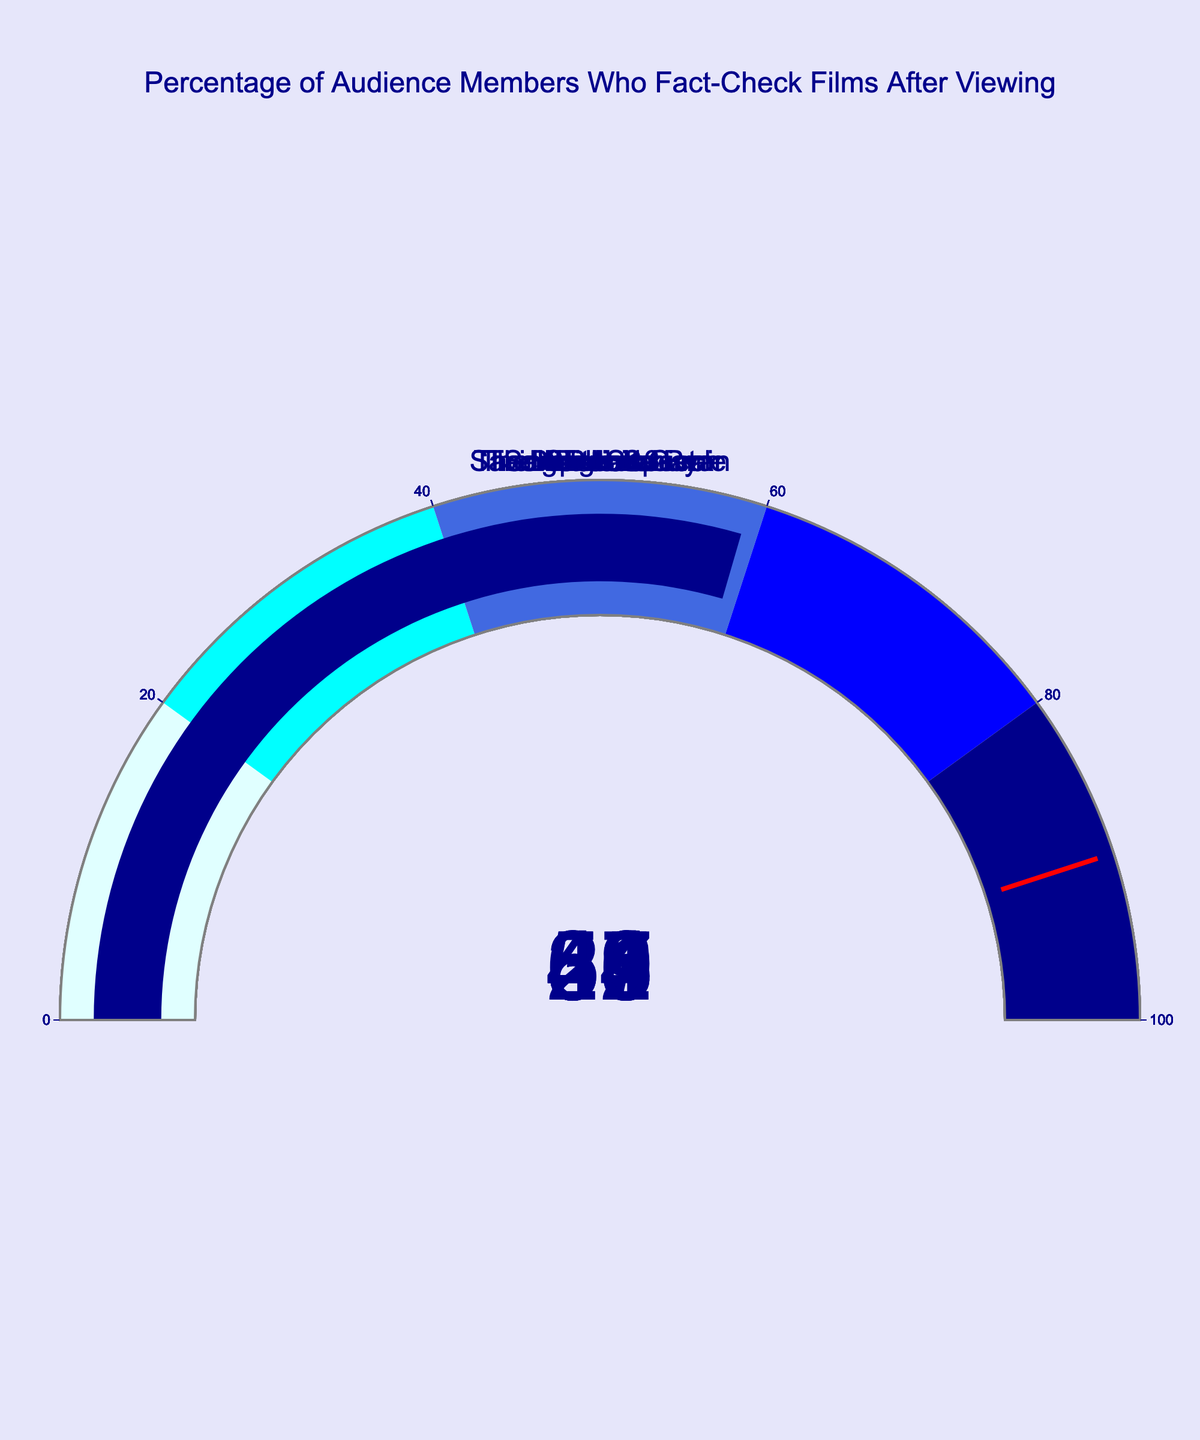what movie has the highest percentage of audience members who fact-check it after viewing? The gauge chart displays different movies with their respective percentages of audience members who fact-check after viewing. By looking at the values, Braveheart has the highest percentage of 68%.
Answer: Braveheart What movie has the lowest percentage of audience members who fact-check it after viewing? The gauge chart displays different movies with their respective percentages. By looking at the values, The King's Speech has the lowest percentage of 28%.
Answer: The King's Speech What is the approximate average percentage of audience members who fact-check these films after viewing? First, sum the percentages for all films: 42 + 68 + 55 + 39 + 31 + 47 + 28 + 36 + 44 + 59 = 449. Then divide by the number of movies, which is 10. 449/10 = 44.9.
Answer: 44.9 Which films have a fact-check percentage greater than 50%? The movies with percentages greater than 50% are Braveheart (68%), Gladiator (55%), and The Last Samurai (59%).
Answer: Braveheart, Gladiator, The Last Samurai How many films have a fact-check percentage between 30% and 50%? The movies in this range are Titanic (42%), The Imitation Game (39%), Lincoln (47%), and Apollo 13 (44%). There are 4 films in this range.
Answer: 4 What is the difference in the fact-check percentage between the highest and lowest films? The highest is Braveheart with 68%, and the lowest is The King's Speech with 28%. The difference is 68 - 28 = 40%.
Answer: 40 Between which two movies is the difference in fact-check percentage the smallest? To find the smallest difference, look for pairs of movies with closely matched percentages. The smallest difference is between Titanic (42%) and Apollo 13 (44%) with a difference of 2%.
Answer: Titanic and Apollo 13 What is the combined percentage of audience members who fact-check films for Braveheart and The Last Samurai? Braveheart has 68% and The Last Samurai has 59%. Their combined percentage is 68 + 59 = 127%.
Answer: 127 What fraction of the films have less than 40% of audience members fact-checking after viewing? The films are The Imitation Game (39%), Saving Private Ryan (31%), The King's Speech (28%), and Schindler's List (36%). There are 4 films out of 10, so the fraction is 4/10 = 2/5.
Answer: 2/5 